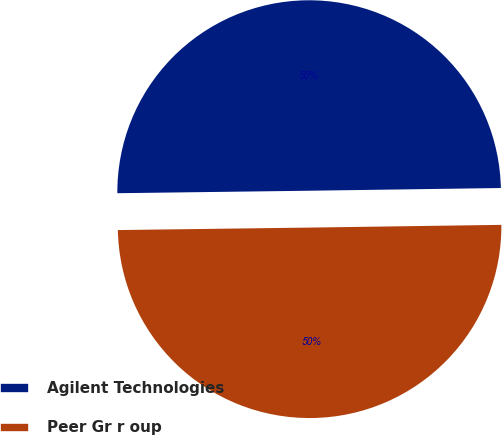<chart> <loc_0><loc_0><loc_500><loc_500><pie_chart><fcel>Agilent Technologies<fcel>Peer Gr r oup<nl><fcel>49.98%<fcel>50.02%<nl></chart> 